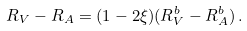Convert formula to latex. <formula><loc_0><loc_0><loc_500><loc_500>R _ { V } - R _ { A } = ( 1 - 2 \xi ) ( R _ { V } ^ { b } - R _ { A } ^ { b } ) \, .</formula> 